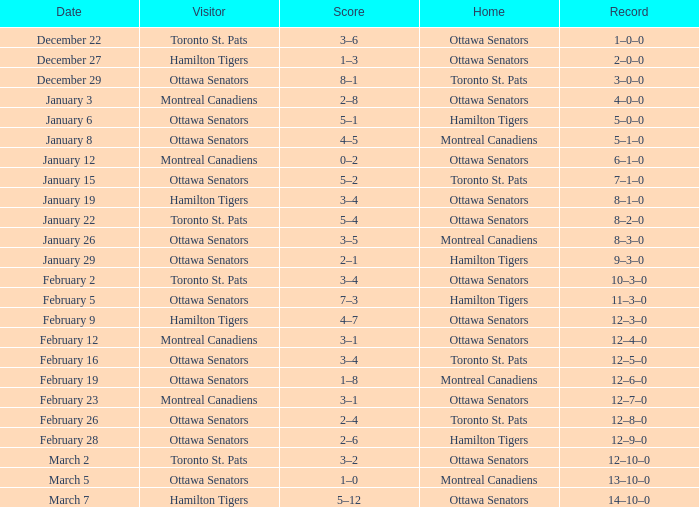What is the outcome for the contest on january 19? 8–1–0. 